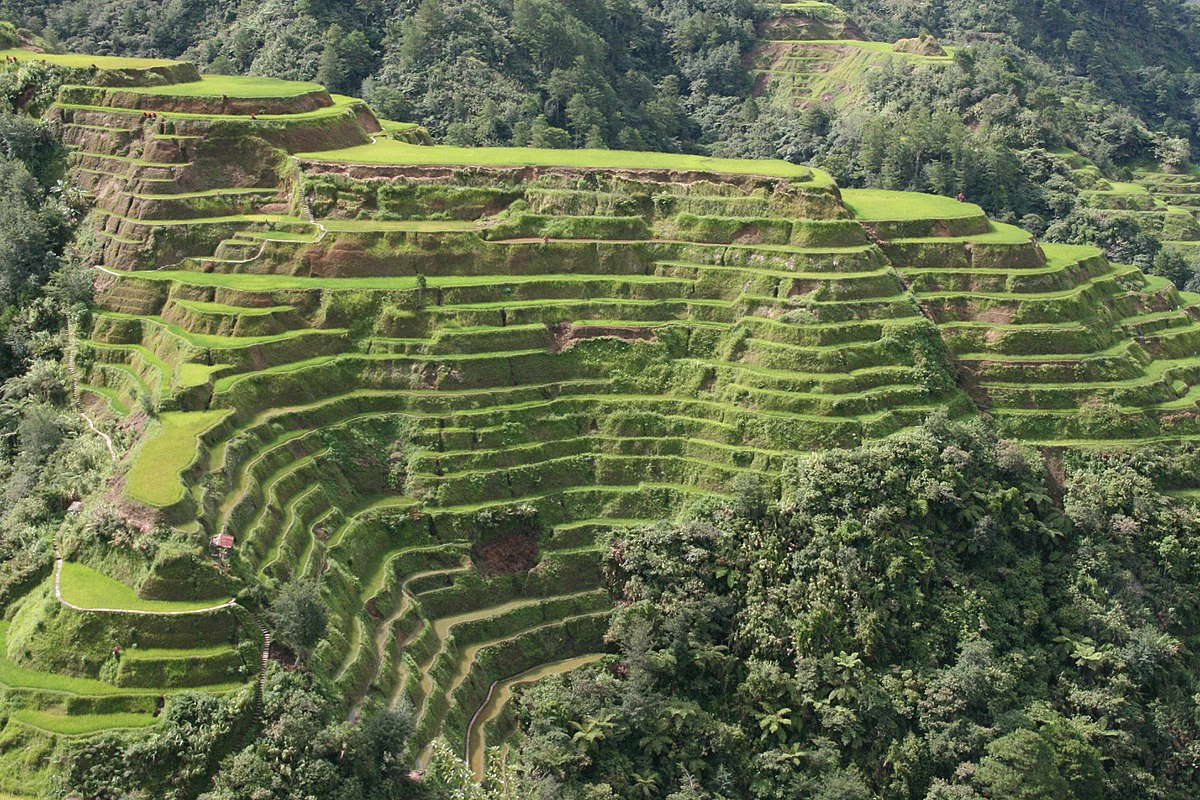How do the locals maintain these terraces? Local farmers in Banaue maintain these rice terraces primarily through manual labor, using traditional tools and methods handed down through generations. Regular maintenance includes clearing the terraces of weeds, repairing the mud walls, and managing the water flow to ensure all terraces receive adequate hydration. Community efforts play a big part in this, as the terraces are not only agricultural assets but also a source of cultural pride. Is there any cultural significance associated with the terraces? Absolutely, the Banaue Rice Terraces are a symbol of the Ifugao people's cultural identity and resilience. Originally built to maximize arable land area in the mountainous region, they have become a central part of local customs and traditions. Festivals, rituals, and daily practices revolve around the planting and harvesting cycles of rice, reflecting an intimate connection between the people and their land. The terraces are not just a place of food production but a living heritage that sustains the cultural fabric of the community. 